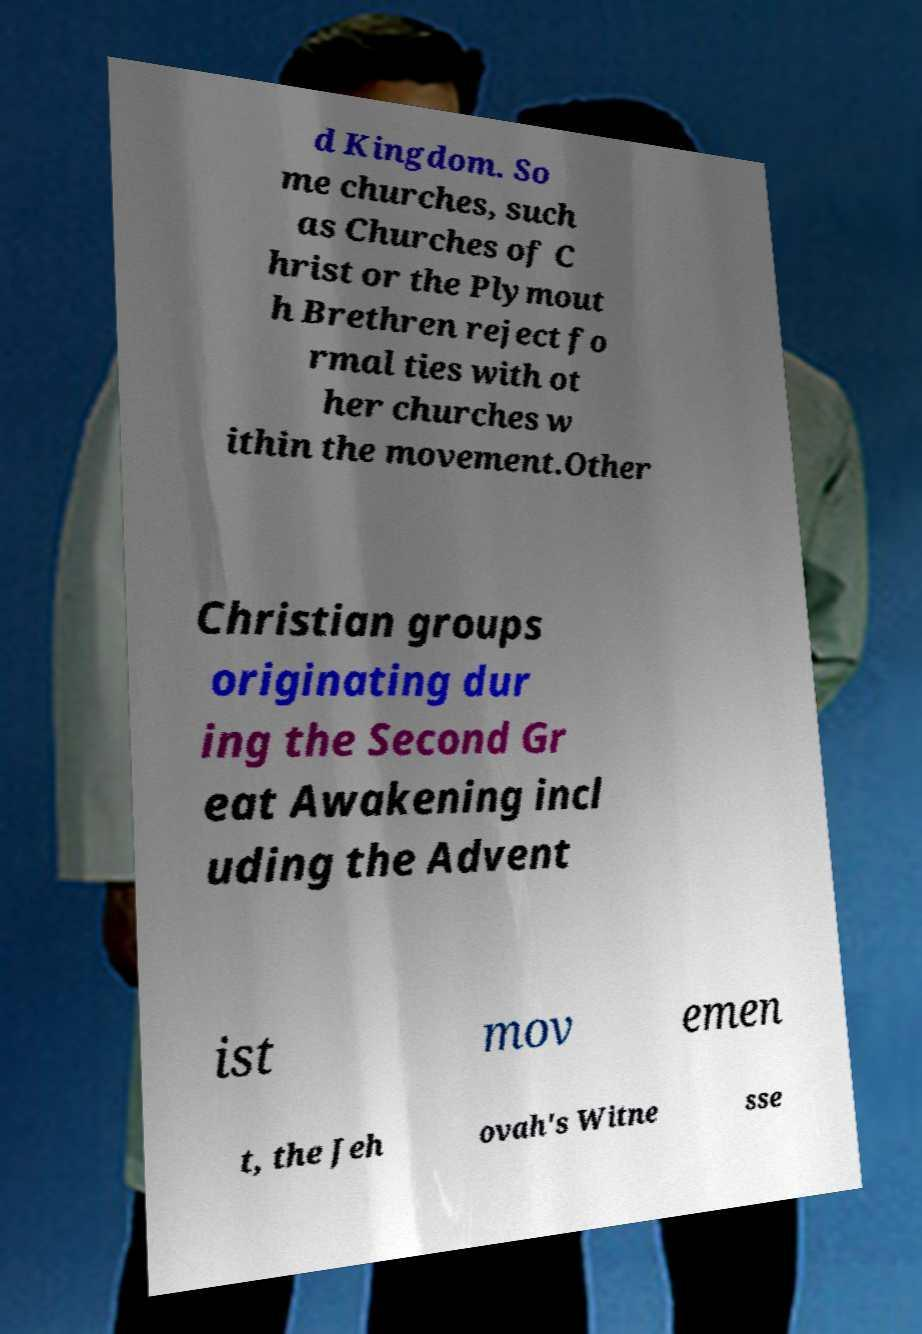Could you extract and type out the text from this image? d Kingdom. So me churches, such as Churches of C hrist or the Plymout h Brethren reject fo rmal ties with ot her churches w ithin the movement.Other Christian groups originating dur ing the Second Gr eat Awakening incl uding the Advent ist mov emen t, the Jeh ovah's Witne sse 